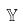Convert formula to latex. <formula><loc_0><loc_0><loc_500><loc_500>\mathbb { Y }</formula> 